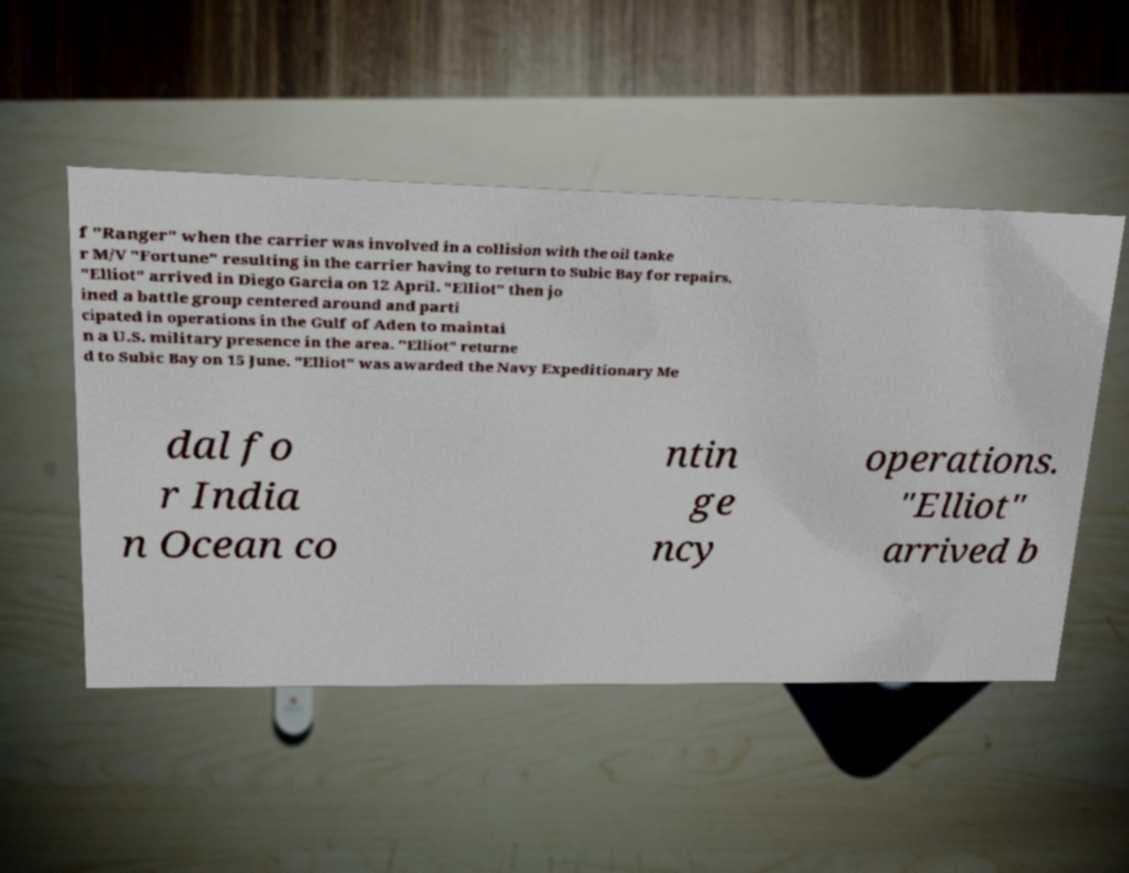There's text embedded in this image that I need extracted. Can you transcribe it verbatim? f "Ranger" when the carrier was involved in a collision with the oil tanke r M/V "Fortune" resulting in the carrier having to return to Subic Bay for repairs. "Elliot" arrived in Diego Garcia on 12 April. "Elliot" then jo ined a battle group centered around and parti cipated in operations in the Gulf of Aden to maintai n a U.S. military presence in the area. "Elliot" returne d to Subic Bay on 15 June. "Elliot" was awarded the Navy Expeditionary Me dal fo r India n Ocean co ntin ge ncy operations. "Elliot" arrived b 